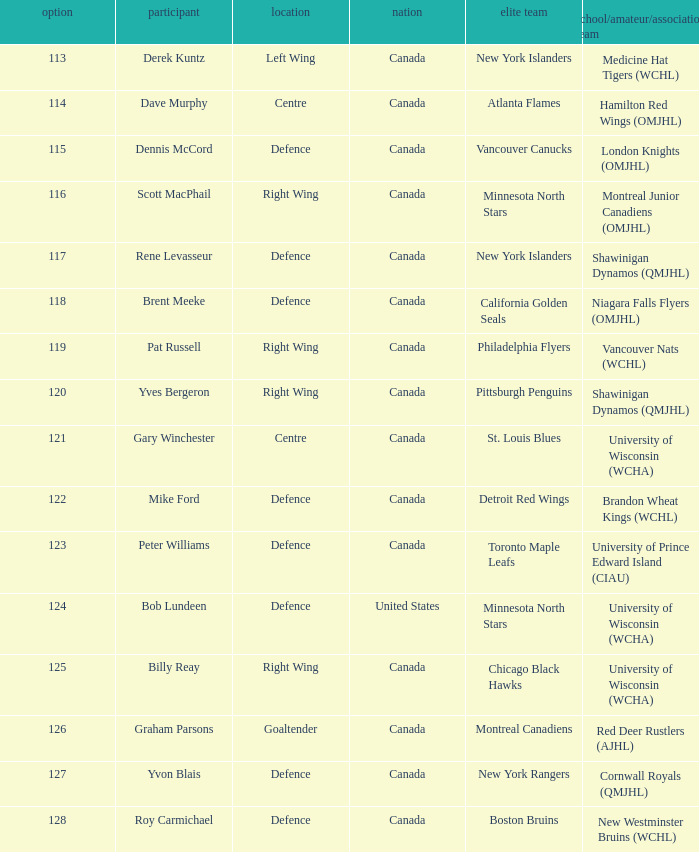Name the position for pick number 128 Defence. 